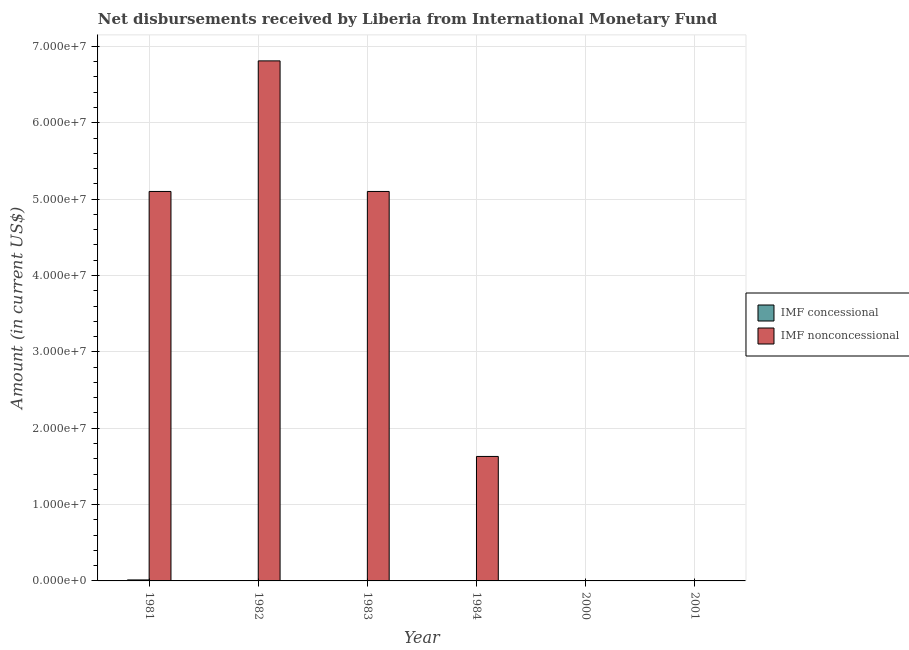How many different coloured bars are there?
Offer a very short reply. 2. Are the number of bars per tick equal to the number of legend labels?
Give a very brief answer. No. What is the net non concessional disbursements from imf in 1983?
Your answer should be very brief. 5.10e+07. Across all years, what is the maximum net concessional disbursements from imf?
Offer a terse response. 1.29e+05. Across all years, what is the minimum net concessional disbursements from imf?
Ensure brevity in your answer.  0. In which year was the net concessional disbursements from imf maximum?
Provide a succinct answer. 1981. What is the total net non concessional disbursements from imf in the graph?
Make the answer very short. 1.86e+08. What is the difference between the net non concessional disbursements from imf in 1981 and that in 1982?
Keep it short and to the point. -1.71e+07. What is the average net non concessional disbursements from imf per year?
Your answer should be compact. 3.11e+07. In the year 1982, what is the difference between the net non concessional disbursements from imf and net concessional disbursements from imf?
Provide a succinct answer. 0. What is the ratio of the net non concessional disbursements from imf in 1981 to that in 1982?
Provide a succinct answer. 0.75. Is the net non concessional disbursements from imf in 1981 less than that in 1984?
Offer a very short reply. No. What is the difference between the highest and the second highest net non concessional disbursements from imf?
Offer a terse response. 1.71e+07. What is the difference between the highest and the lowest net concessional disbursements from imf?
Provide a succinct answer. 1.29e+05. Is the sum of the net non concessional disbursements from imf in 1982 and 1983 greater than the maximum net concessional disbursements from imf across all years?
Make the answer very short. Yes. Are all the bars in the graph horizontal?
Ensure brevity in your answer.  No. How many years are there in the graph?
Make the answer very short. 6. Are the values on the major ticks of Y-axis written in scientific E-notation?
Your answer should be very brief. Yes. Does the graph contain grids?
Your response must be concise. Yes. How many legend labels are there?
Your answer should be compact. 2. What is the title of the graph?
Make the answer very short. Net disbursements received by Liberia from International Monetary Fund. Does "Primary school" appear as one of the legend labels in the graph?
Provide a succinct answer. No. What is the label or title of the X-axis?
Provide a succinct answer. Year. What is the Amount (in current US$) of IMF concessional in 1981?
Your answer should be compact. 1.29e+05. What is the Amount (in current US$) in IMF nonconcessional in 1981?
Your response must be concise. 5.10e+07. What is the Amount (in current US$) of IMF concessional in 1982?
Provide a short and direct response. 0. What is the Amount (in current US$) of IMF nonconcessional in 1982?
Provide a succinct answer. 6.81e+07. What is the Amount (in current US$) of IMF concessional in 1983?
Your answer should be very brief. 0. What is the Amount (in current US$) of IMF nonconcessional in 1983?
Your answer should be compact. 5.10e+07. What is the Amount (in current US$) of IMF concessional in 1984?
Your answer should be compact. 0. What is the Amount (in current US$) of IMF nonconcessional in 1984?
Your answer should be compact. 1.63e+07. Across all years, what is the maximum Amount (in current US$) of IMF concessional?
Offer a terse response. 1.29e+05. Across all years, what is the maximum Amount (in current US$) in IMF nonconcessional?
Your response must be concise. 6.81e+07. What is the total Amount (in current US$) in IMF concessional in the graph?
Your answer should be compact. 1.29e+05. What is the total Amount (in current US$) of IMF nonconcessional in the graph?
Give a very brief answer. 1.86e+08. What is the difference between the Amount (in current US$) in IMF nonconcessional in 1981 and that in 1982?
Provide a short and direct response. -1.71e+07. What is the difference between the Amount (in current US$) in IMF nonconcessional in 1981 and that in 1984?
Offer a terse response. 3.47e+07. What is the difference between the Amount (in current US$) in IMF nonconcessional in 1982 and that in 1983?
Your answer should be very brief. 1.71e+07. What is the difference between the Amount (in current US$) in IMF nonconcessional in 1982 and that in 1984?
Make the answer very short. 5.18e+07. What is the difference between the Amount (in current US$) of IMF nonconcessional in 1983 and that in 1984?
Provide a succinct answer. 3.47e+07. What is the difference between the Amount (in current US$) of IMF concessional in 1981 and the Amount (in current US$) of IMF nonconcessional in 1982?
Provide a short and direct response. -6.80e+07. What is the difference between the Amount (in current US$) in IMF concessional in 1981 and the Amount (in current US$) in IMF nonconcessional in 1983?
Make the answer very short. -5.09e+07. What is the difference between the Amount (in current US$) of IMF concessional in 1981 and the Amount (in current US$) of IMF nonconcessional in 1984?
Your answer should be very brief. -1.62e+07. What is the average Amount (in current US$) of IMF concessional per year?
Provide a succinct answer. 2.15e+04. What is the average Amount (in current US$) of IMF nonconcessional per year?
Your answer should be very brief. 3.11e+07. In the year 1981, what is the difference between the Amount (in current US$) of IMF concessional and Amount (in current US$) of IMF nonconcessional?
Keep it short and to the point. -5.09e+07. What is the ratio of the Amount (in current US$) in IMF nonconcessional in 1981 to that in 1982?
Offer a very short reply. 0.75. What is the ratio of the Amount (in current US$) in IMF nonconcessional in 1981 to that in 1984?
Your response must be concise. 3.13. What is the ratio of the Amount (in current US$) in IMF nonconcessional in 1982 to that in 1983?
Give a very brief answer. 1.34. What is the ratio of the Amount (in current US$) in IMF nonconcessional in 1982 to that in 1984?
Provide a succinct answer. 4.18. What is the ratio of the Amount (in current US$) of IMF nonconcessional in 1983 to that in 1984?
Your answer should be compact. 3.13. What is the difference between the highest and the second highest Amount (in current US$) in IMF nonconcessional?
Provide a short and direct response. 1.71e+07. What is the difference between the highest and the lowest Amount (in current US$) in IMF concessional?
Keep it short and to the point. 1.29e+05. What is the difference between the highest and the lowest Amount (in current US$) of IMF nonconcessional?
Your answer should be compact. 6.81e+07. 